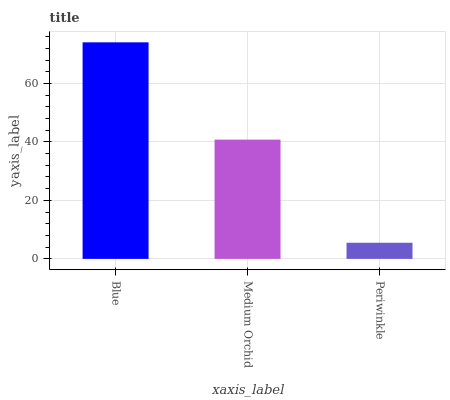Is Periwinkle the minimum?
Answer yes or no. Yes. Is Blue the maximum?
Answer yes or no. Yes. Is Medium Orchid the minimum?
Answer yes or no. No. Is Medium Orchid the maximum?
Answer yes or no. No. Is Blue greater than Medium Orchid?
Answer yes or no. Yes. Is Medium Orchid less than Blue?
Answer yes or no. Yes. Is Medium Orchid greater than Blue?
Answer yes or no. No. Is Blue less than Medium Orchid?
Answer yes or no. No. Is Medium Orchid the high median?
Answer yes or no. Yes. Is Medium Orchid the low median?
Answer yes or no. Yes. Is Periwinkle the high median?
Answer yes or no. No. Is Blue the low median?
Answer yes or no. No. 